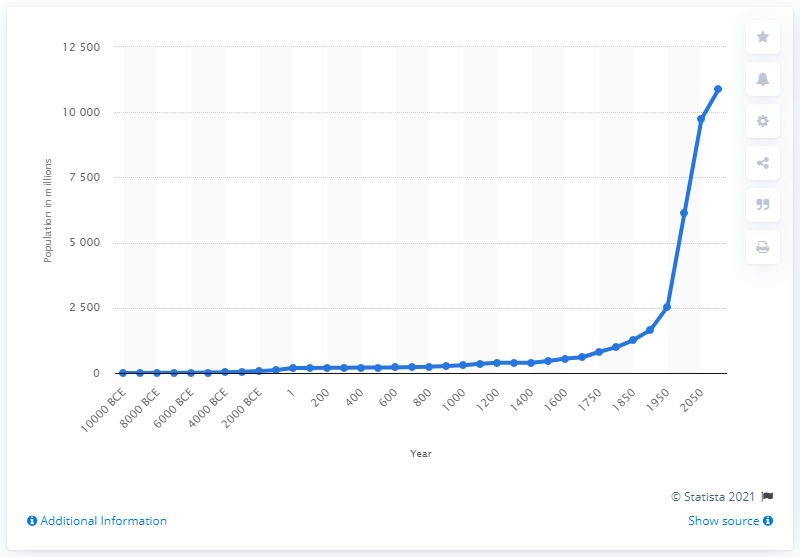Outline some significant characteristics in this image. The population of the world began to grow slowly and steadily in the year 1900. 